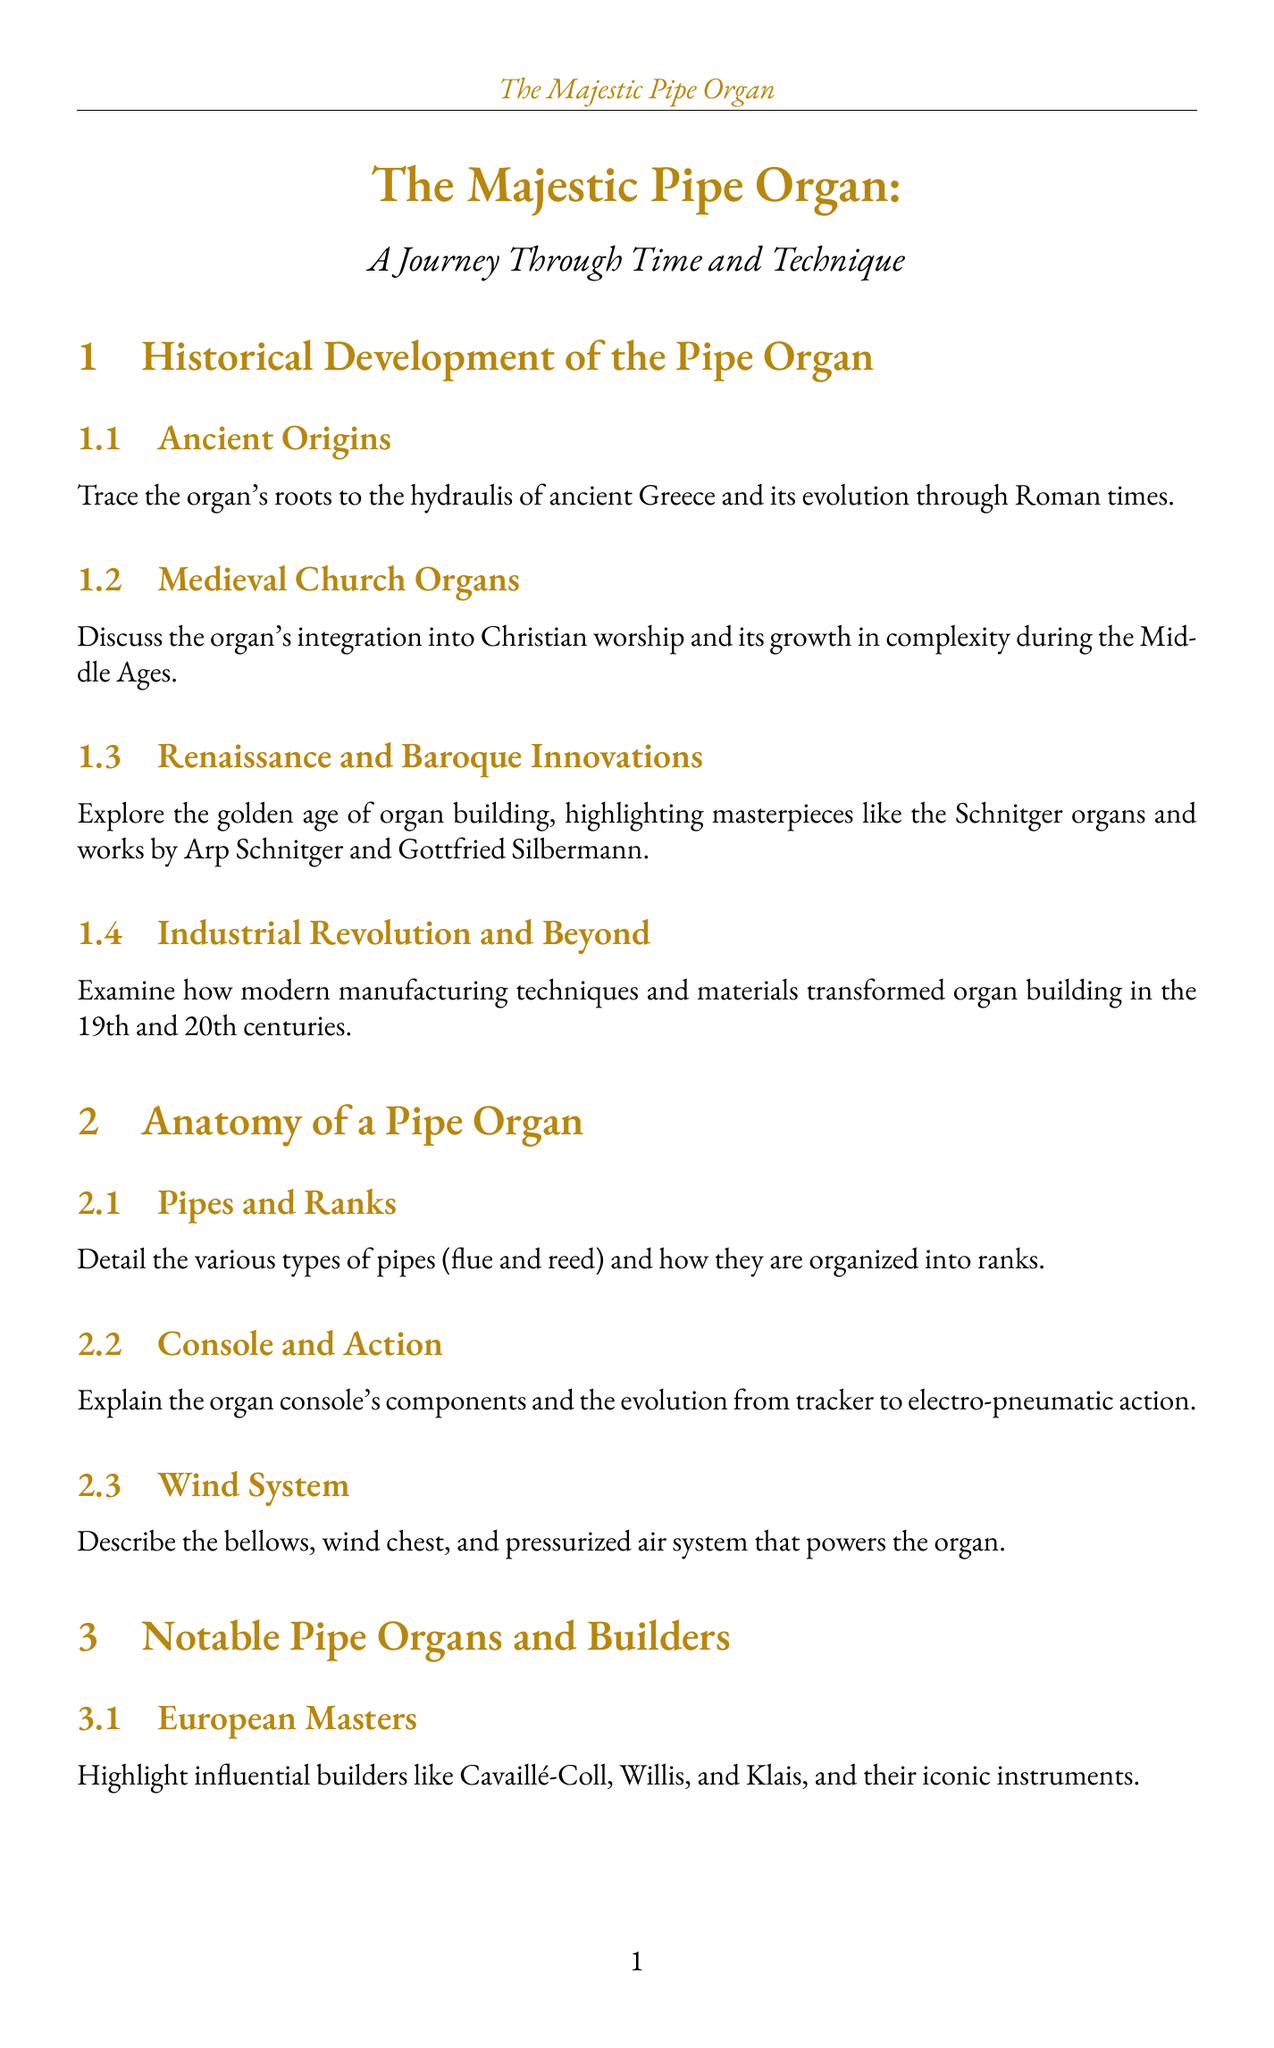What are the ancient origins of the pipe organ? The document states that the organ's roots trace back to the hydraulis of ancient Greece.
Answer: hydraulis of ancient Greece Which builders are highlighted as European masters? The document mentions influential builders like Cavaillé-Coll, Willis, and Klais.
Answer: Cavaillé-Coll, Willis, Klais What is a key maintenance practice for pipe organs? The document outlines routine tasks that include cleaning, lubrication, and minor repairs.
Answer: cleaning, lubrication, minor repairs Who contributed to American organ building innovations? The document discusses contributions by builders such as Ernest M. Skinner and the Aeolian-Skinner company.
Answer: Ernest M. Skinner, Aeolian-Skinner company What modern masterpiece is featured in the report? The walt Disney Concert Hall organ by Glatter-Götz is mentioned as a contemporary organ.
Answer: Walt Disney Concert Hall organ by Glatter-Götz What is the importance of temperature stability in pipe tuning? The document explains that temperature stability is significant during the tuning process of different types of pipes.
Answer: temperature stability What does the report say about digital organ technology? The document explores the development of digital organ technology as it relates to traditional pipe organs.
Answer: digital organ technology What organization is dedicated to preserving historic instruments? The document highlights the Organ Historical Society for its efforts in preservation.
Answer: Organ Historical Society 